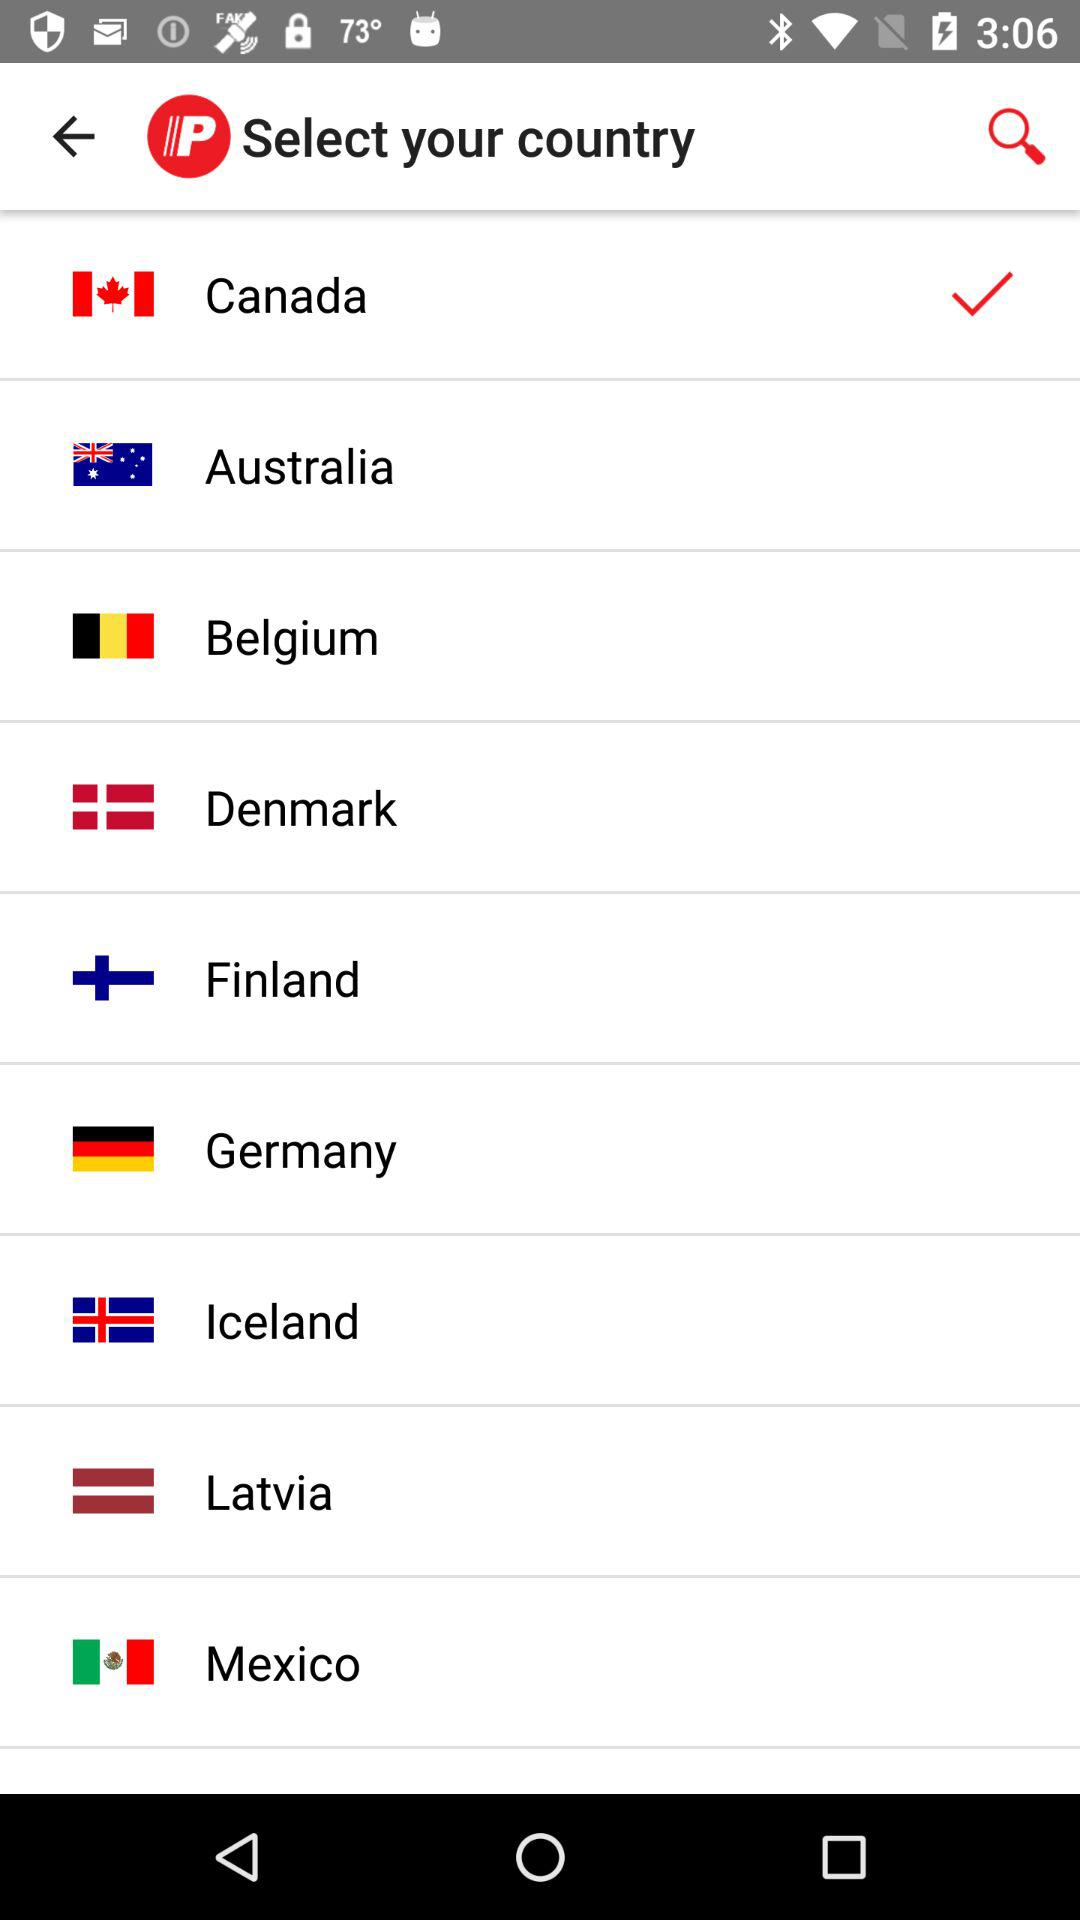How many countries have check marks next to them?
Answer the question using a single word or phrase. 1 